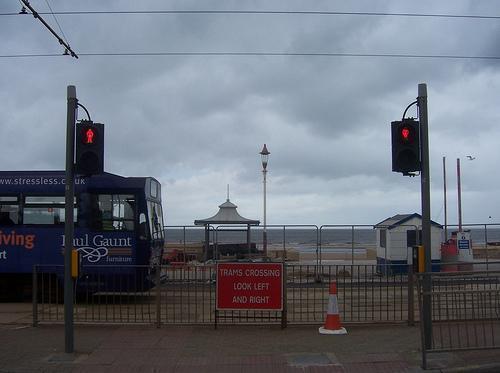Seeing dark clouds in the sky will remind you to bring what accessory that would be helpful if it starts to rain?
Indicate the correct choice and explain in the format: 'Answer: answer
Rationale: rationale.'
Options: Necklace, eyeglasses, umbrella, watch. Answer: umbrella.
Rationale: It looks cloudy and dark like it may rain. 